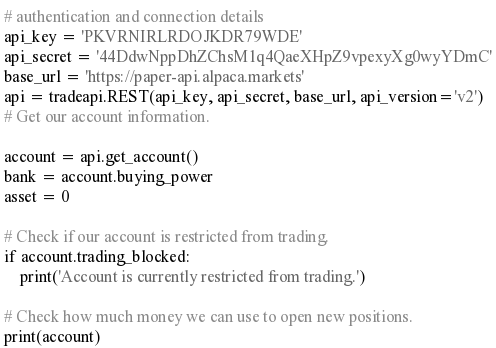Convert code to text. <code><loc_0><loc_0><loc_500><loc_500><_Python_># authentication and connection details
api_key = 'PKVRNIRLRDOJKDR79WDE'
api_secret = '44DdwNppDhZChsM1q4QaeXHpZ9vpexyXg0wyYDmC'
base_url = 'https://paper-api.alpaca.markets'
api = tradeapi.REST(api_key, api_secret, base_url, api_version='v2')
# Get our account information.

account = api.get_account()
bank = account.buying_power
asset = 0

# Check if our account is restricted from trading.
if account.trading_blocked:
    print('Account is currently restricted from trading.')

# Check how much money we can use to open new positions.
print(account)
</code> 